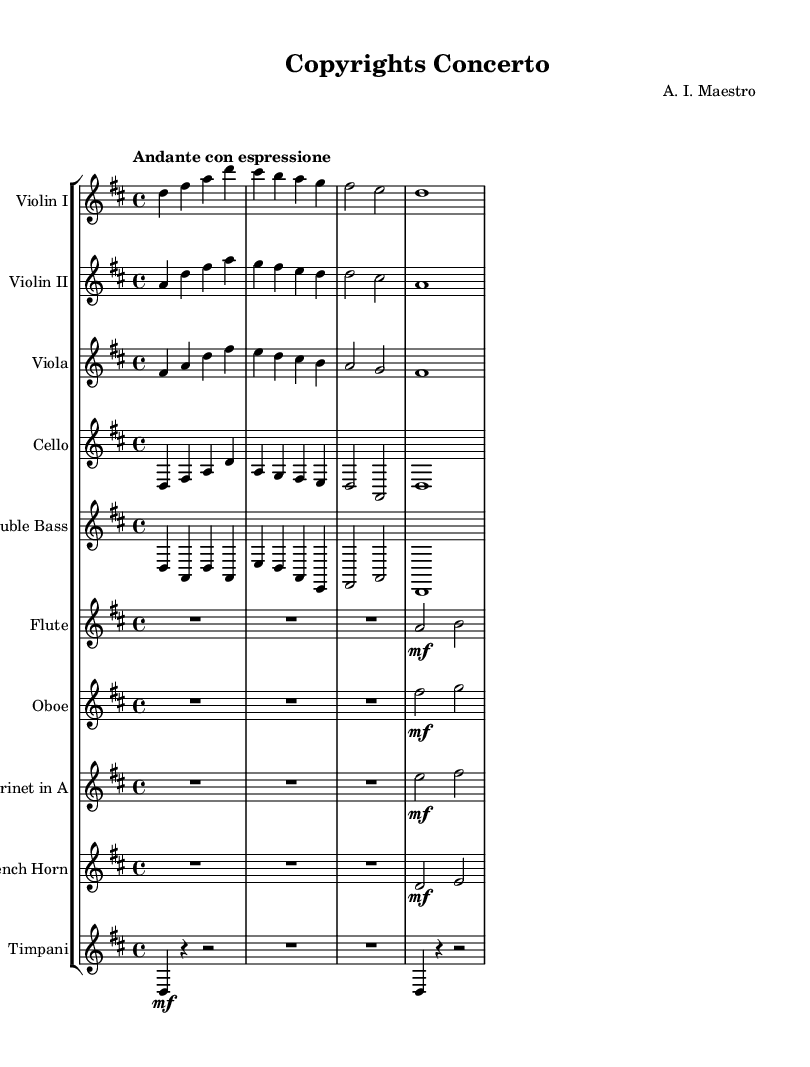What is the key signature of this music? The key signature indicated at the beginning of the score shows two sharps, which signifies that the music is in D major.
Answer: D major What is the time signature of this composition? The time signature is represented at the beginning of the score as 4/4, meaning there are four beats in each measure.
Answer: 4/4 What is the tempo marking of this piece? The tempo marking specified in the music indicates "Andante con espressione," suggesting a moderately slow tempo with expression.
Answer: Andante con espressione Which instruments are featured in this orchestral composition? The orchestration includes strings, woodwinds, and brass, specifically stating Violin I, Violin II, Viola, Cello, Double Bass, Flute, Oboe, Clarinet, French Horn, and Timpani.
Answer: Violin I, Violin II, Viola, Cello, Double Bass, Flute, Oboe, Clarinet, French Horn, Timpani How many measures are present in the main orchestral section? By analyzing the music, it is evident that there are a total of eight measures presented in this section.
Answer: Eight What is the texture of this orchestral piece? The texture can be described as homophonic, where the melody is supported by harmonic accompaniment provided by accompanying instruments.
Answer: Homophonic Which instrument plays the main melody in the opening section? The opening melody is primarily carried by the first violin, which plays the most prominent melodic line throughout.
Answer: Violin I 